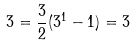Convert formula to latex. <formula><loc_0><loc_0><loc_500><loc_500>3 = \frac { 3 } { 2 } ( 3 ^ { 1 } - 1 ) = 3</formula> 